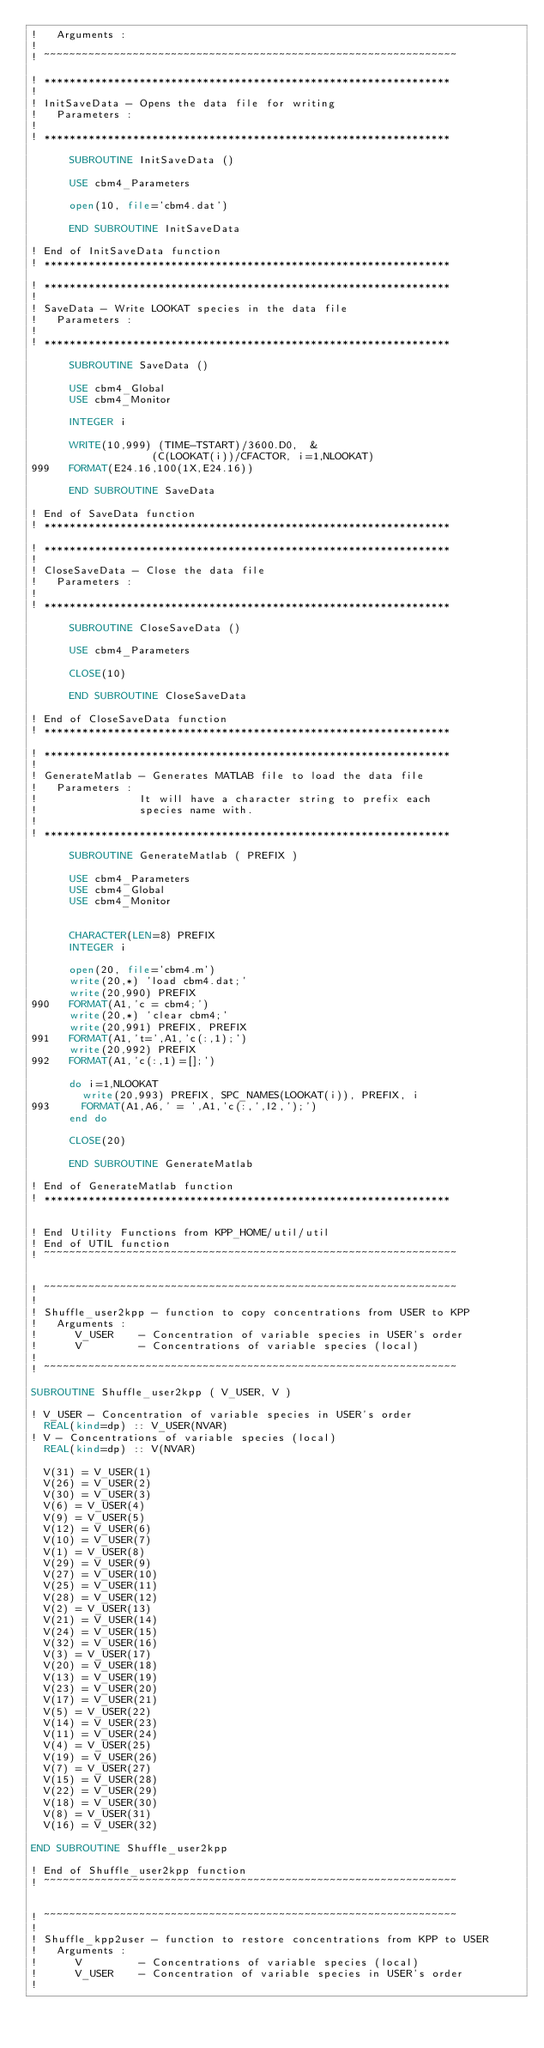Convert code to text. <code><loc_0><loc_0><loc_500><loc_500><_FORTRAN_>!   Arguments :
! 
! ~~~~~~~~~~~~~~~~~~~~~~~~~~~~~~~~~~~~~~~~~~~~~~~~~~~~~~~~~~~~~~~~~

! ****************************************************************
!                            
! InitSaveData - Opens the data file for writing
!   Parameters :                                                  
!
! ****************************************************************

      SUBROUTINE InitSaveData ()

      USE cbm4_Parameters

      open(10, file='cbm4.dat')

      END SUBROUTINE InitSaveData

! End of InitSaveData function
! ****************************************************************

! ****************************************************************
!                            
! SaveData - Write LOOKAT species in the data file 
!   Parameters :                                                  
!
! ****************************************************************

      SUBROUTINE SaveData ()

      USE cbm4_Global
      USE cbm4_Monitor

      INTEGER i

      WRITE(10,999) (TIME-TSTART)/3600.D0,  &
                   (C(LOOKAT(i))/CFACTOR, i=1,NLOOKAT)
999   FORMAT(E24.16,100(1X,E24.16))

      END SUBROUTINE SaveData

! End of SaveData function
! ****************************************************************

! ****************************************************************
!                            
! CloseSaveData - Close the data file 
!   Parameters :                                                  
!
! ****************************************************************

      SUBROUTINE CloseSaveData ()

      USE cbm4_Parameters

      CLOSE(10)

      END SUBROUTINE CloseSaveData

! End of CloseSaveData function
! ****************************************************************

! ****************************************************************
!                            
! GenerateMatlab - Generates MATLAB file to load the data file 
!   Parameters : 
!                It will have a character string to prefix each 
!                species name with.                                                 
!
! ****************************************************************

      SUBROUTINE GenerateMatlab ( PREFIX )

      USE cbm4_Parameters
      USE cbm4_Global
      USE cbm4_Monitor

      
      CHARACTER(LEN=8) PREFIX 
      INTEGER i

      open(20, file='cbm4.m')
      write(20,*) 'load cbm4.dat;'
      write(20,990) PREFIX
990   FORMAT(A1,'c = cbm4;')
      write(20,*) 'clear cbm4;'
      write(20,991) PREFIX, PREFIX
991   FORMAT(A1,'t=',A1,'c(:,1);')
      write(20,992) PREFIX
992   FORMAT(A1,'c(:,1)=[];')

      do i=1,NLOOKAT
        write(20,993) PREFIX, SPC_NAMES(LOOKAT(i)), PREFIX, i
993     FORMAT(A1,A6,' = ',A1,'c(:,',I2,');')
      end do
      
      CLOSE(20)

      END SUBROUTINE GenerateMatlab

! End of GenerateMatlab function
! ****************************************************************


! End Utility Functions from KPP_HOME/util/util
! End of UTIL function
! ~~~~~~~~~~~~~~~~~~~~~~~~~~~~~~~~~~~~~~~~~~~~~~~~~~~~~~~~~~~~~~~~~


! ~~~~~~~~~~~~~~~~~~~~~~~~~~~~~~~~~~~~~~~~~~~~~~~~~~~~~~~~~~~~~~~~~
! 
! Shuffle_user2kpp - function to copy concentrations from USER to KPP
!   Arguments :
!      V_USER    - Concentration of variable species in USER's order
!      V         - Concentrations of variable species (local)
! 
! ~~~~~~~~~~~~~~~~~~~~~~~~~~~~~~~~~~~~~~~~~~~~~~~~~~~~~~~~~~~~~~~~~

SUBROUTINE Shuffle_user2kpp ( V_USER, V )

! V_USER - Concentration of variable species in USER's order
  REAL(kind=dp) :: V_USER(NVAR)
! V - Concentrations of variable species (local)
  REAL(kind=dp) :: V(NVAR)

  V(31) = V_USER(1)
  V(26) = V_USER(2)
  V(30) = V_USER(3)
  V(6) = V_USER(4)
  V(9) = V_USER(5)
  V(12) = V_USER(6)
  V(10) = V_USER(7)
  V(1) = V_USER(8)
  V(29) = V_USER(9)
  V(27) = V_USER(10)
  V(25) = V_USER(11)
  V(28) = V_USER(12)
  V(2) = V_USER(13)
  V(21) = V_USER(14)
  V(24) = V_USER(15)
  V(32) = V_USER(16)
  V(3) = V_USER(17)
  V(20) = V_USER(18)
  V(13) = V_USER(19)
  V(23) = V_USER(20)
  V(17) = V_USER(21)
  V(5) = V_USER(22)
  V(14) = V_USER(23)
  V(11) = V_USER(24)
  V(4) = V_USER(25)
  V(19) = V_USER(26)
  V(7) = V_USER(27)
  V(15) = V_USER(28)
  V(22) = V_USER(29)
  V(18) = V_USER(30)
  V(8) = V_USER(31)
  V(16) = V_USER(32)
      
END SUBROUTINE Shuffle_user2kpp

! End of Shuffle_user2kpp function
! ~~~~~~~~~~~~~~~~~~~~~~~~~~~~~~~~~~~~~~~~~~~~~~~~~~~~~~~~~~~~~~~~~


! ~~~~~~~~~~~~~~~~~~~~~~~~~~~~~~~~~~~~~~~~~~~~~~~~~~~~~~~~~~~~~~~~~
! 
! Shuffle_kpp2user - function to restore concentrations from KPP to USER
!   Arguments :
!      V         - Concentrations of variable species (local)
!      V_USER    - Concentration of variable species in USER's order
! </code> 